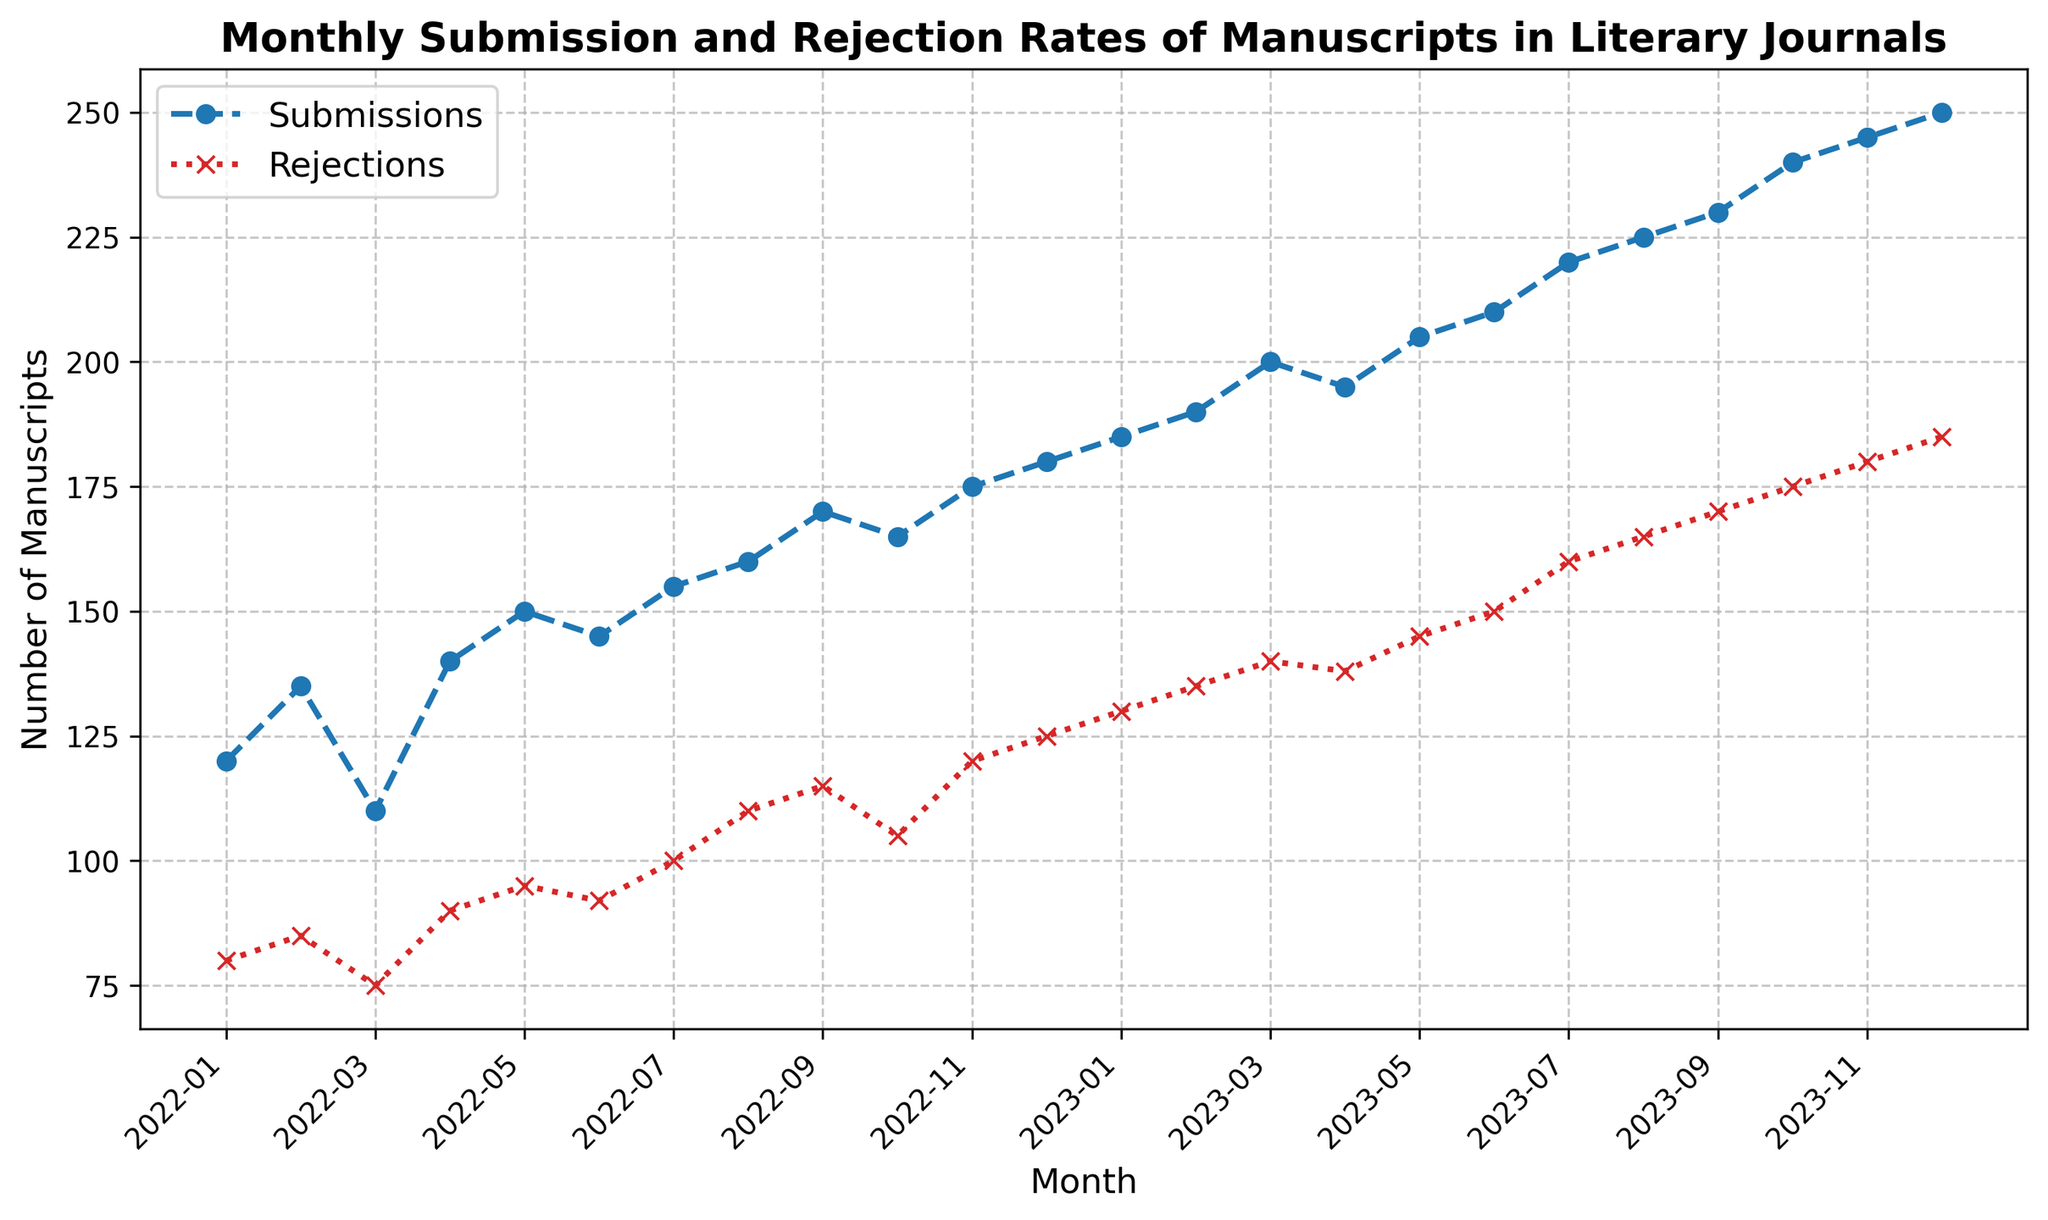What is the total number of submissions in 2022? Sum the submissions from January 2022 to December 2022: 120 + 135 + 110 + 140 + 150 + 145 + 155 + 160 + 170 + 165 + 175 + 180 = 1805
Answer: 1805 How does the number of rejections in August 2022 compare to August 2023? Check the rejections for both August 2022 (110) and August 2023 (165). August 2023 has more rejections.
Answer: August 2023 has more rejections What is the trend in submissions over the two-year period shown? Analyzing the plot from Jan 2022 to Dec 2023, there is a general upward trend in submissions.
Answer: Upward trend What is the average monthly rejection rate in the year 2023? Average the rejections from Jan 2023 to Dec 2023: (130 + 135 + 140 + 138 + 145 + 150 + 160 + 165 + 170 + 175 + 180 + 185) / 12 = 151.25
Answer: 151.25 In which month do rejections surpass 150 for the first time? From the plot, July 2023 is the first month the rejections exceed 150 (160 rejections).
Answer: July 2023 Compare the total rejections in the first half of 2022 with the second half of 2022. Sum rejections in the first half (80 + 85 + 75 + 90 + 95 + 92) = 517 and the second half (100 + 110 + 115 + 105 + 120 + 125) = 675. The second half has more rejections.
Answer: Second half has more Does any month show a decrease in submissions from the previous month? Compare monthly submissions, March 2022 (110) has fewer submissions than February 2022 (135).
Answer: March 2022 Which month in 2023 has the highest number of submissions? December 2023 has the highest number of submissions with 250.
Answer: December 2023 